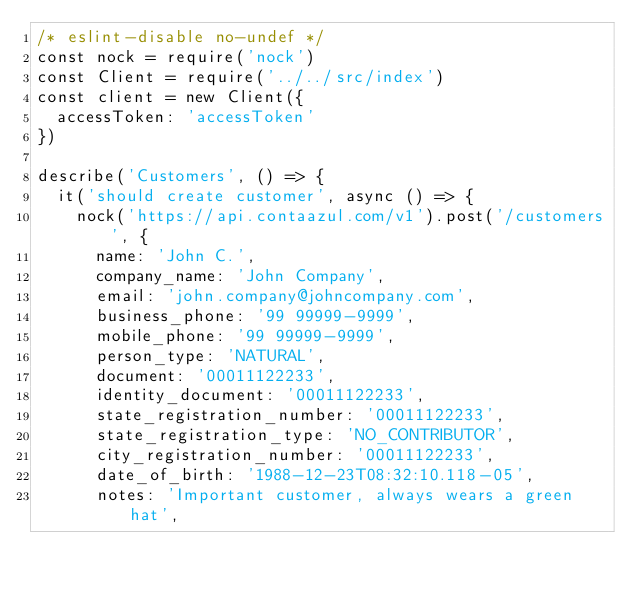Convert code to text. <code><loc_0><loc_0><loc_500><loc_500><_JavaScript_>/* eslint-disable no-undef */
const nock = require('nock')
const Client = require('../../src/index')
const client = new Client({
  accessToken: 'accessToken'
})

describe('Customers', () => {
  it('should create customer', async () => {
    nock('https://api.contaazul.com/v1').post('/customers', {
      name: 'John C.',
      company_name: 'John Company',
      email: 'john.company@johncompany.com',
      business_phone: '99 99999-9999',
      mobile_phone: '99 99999-9999',
      person_type: 'NATURAL',
      document: '00011122233',
      identity_document: '00011122233',
      state_registration_number: '00011122233',
      state_registration_type: 'NO_CONTRIBUTOR',
      city_registration_number: '00011122233',
      date_of_birth: '1988-12-23T08:32:10.118-05',
      notes: 'Important customer, always wears a green hat',</code> 